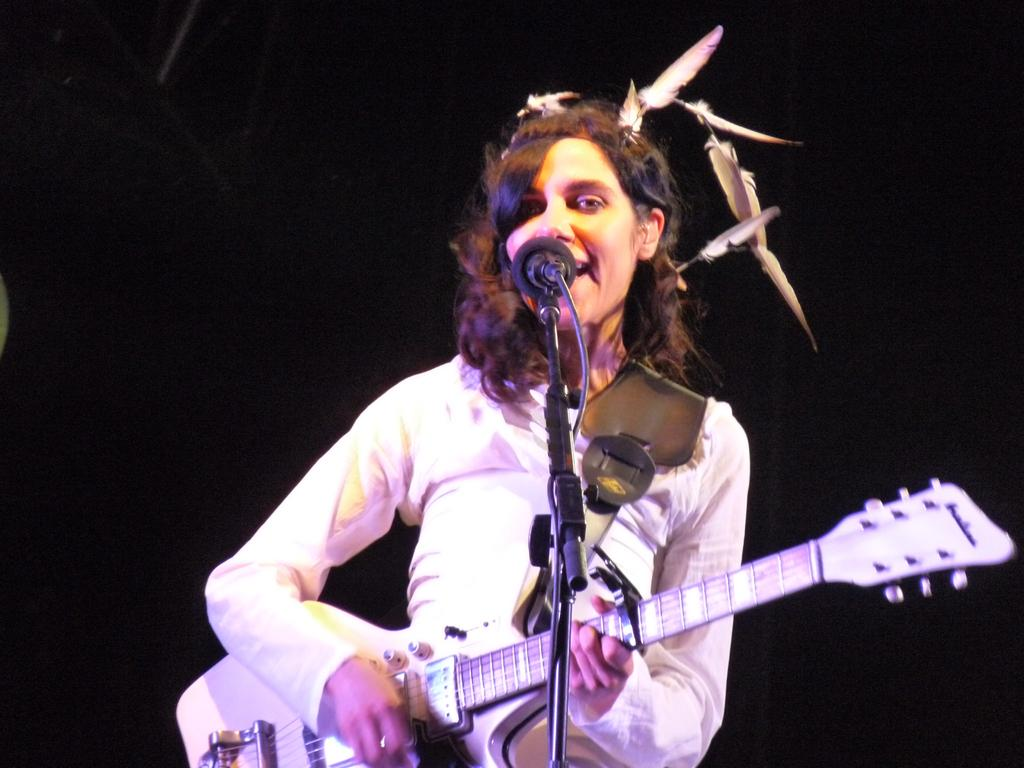Who is the main subject in the image? There is a woman in the image. What is the woman doing in the image? The woman is singing and playing a guitar. What object is present in the image that is typically used for amplifying sound? There is a microphone in the image. What type of underwear is the woman wearing in the image? There is no information about the woman's underwear in the image, and therefore it cannot be determined. 